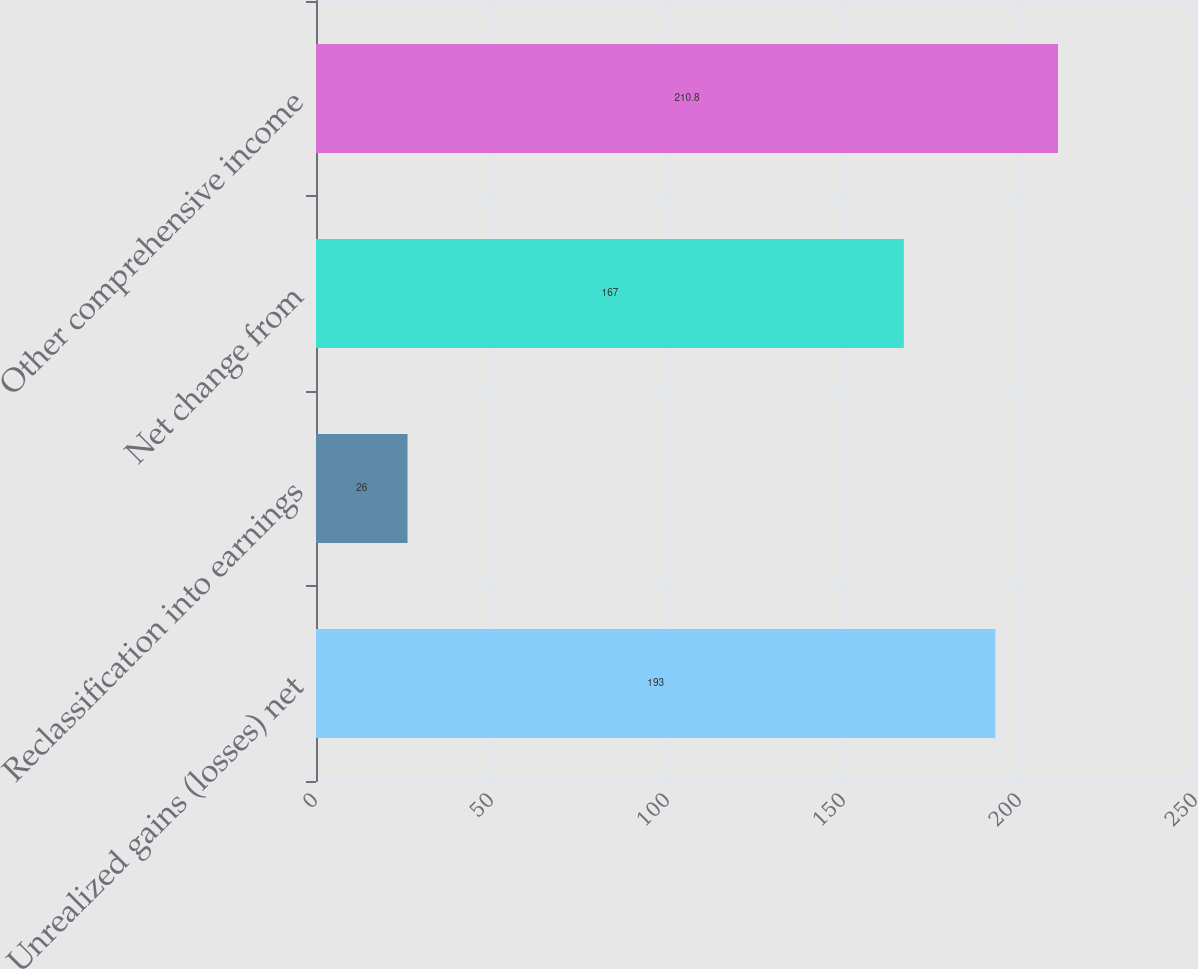Convert chart to OTSL. <chart><loc_0><loc_0><loc_500><loc_500><bar_chart><fcel>Unrealized gains (losses) net<fcel>Reclassification into earnings<fcel>Net change from<fcel>Other comprehensive income<nl><fcel>193<fcel>26<fcel>167<fcel>210.8<nl></chart> 